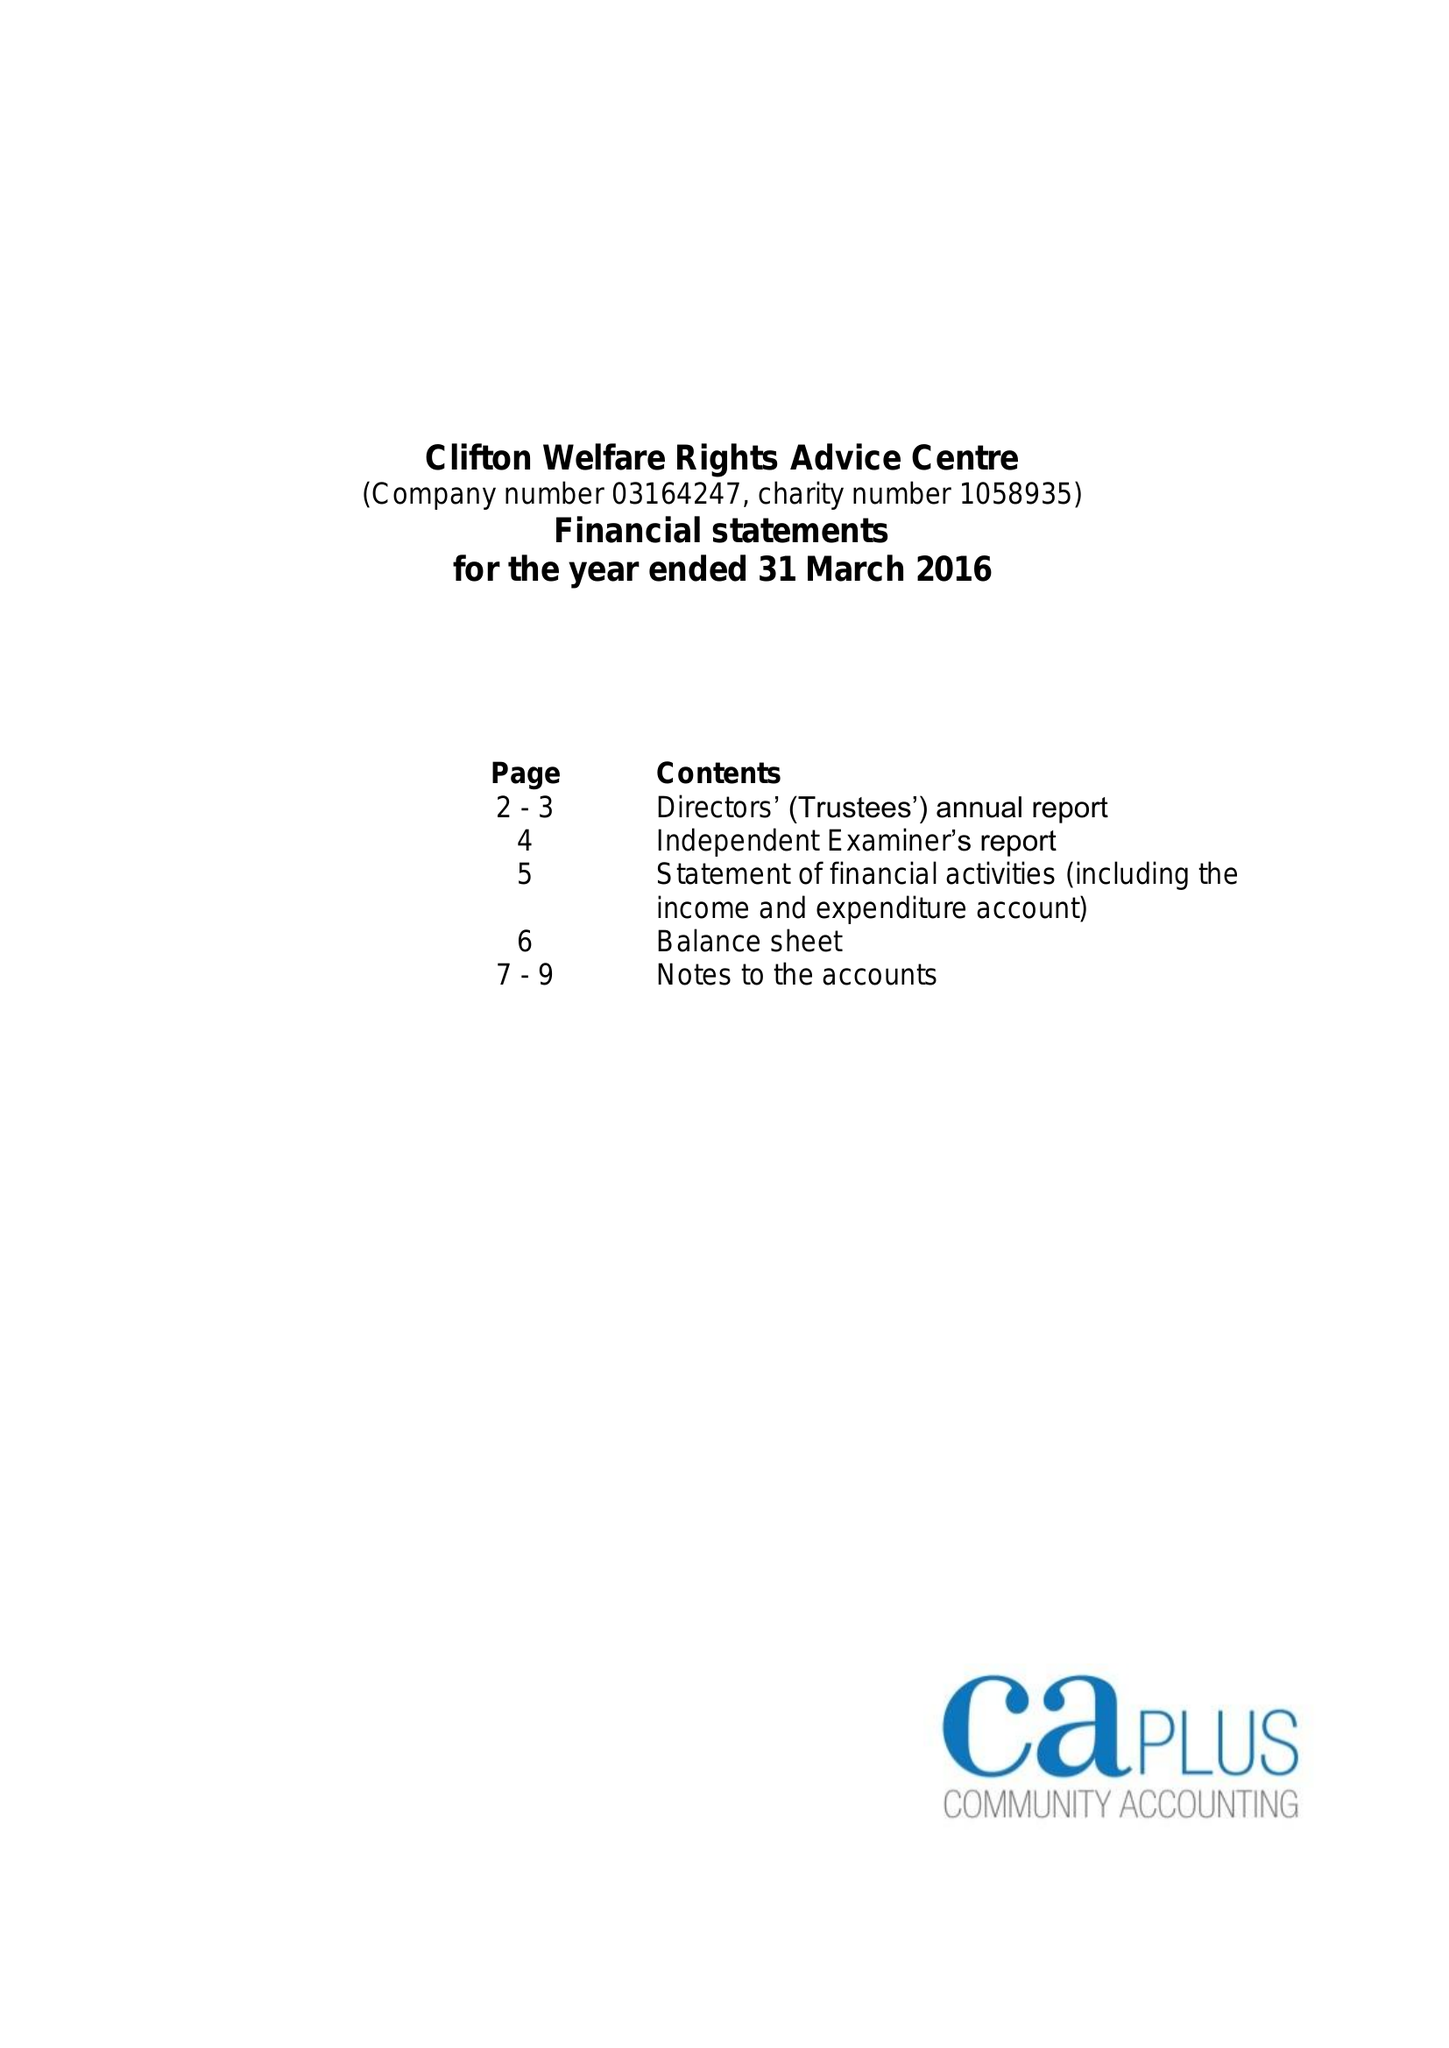What is the value for the charity_name?
Answer the question using a single word or phrase. Clifton Welfare Rights Advice Centre 